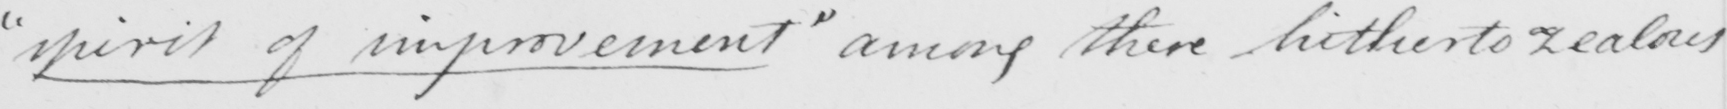Can you tell me what this handwritten text says? " spirit of improvement "  among there hitherto zealous 